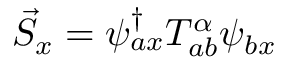<formula> <loc_0><loc_0><loc_500><loc_500>\vec { S } _ { x } = \psi _ { a x } ^ { \dagger } T _ { a b } ^ { \alpha } \psi _ { b x }</formula> 